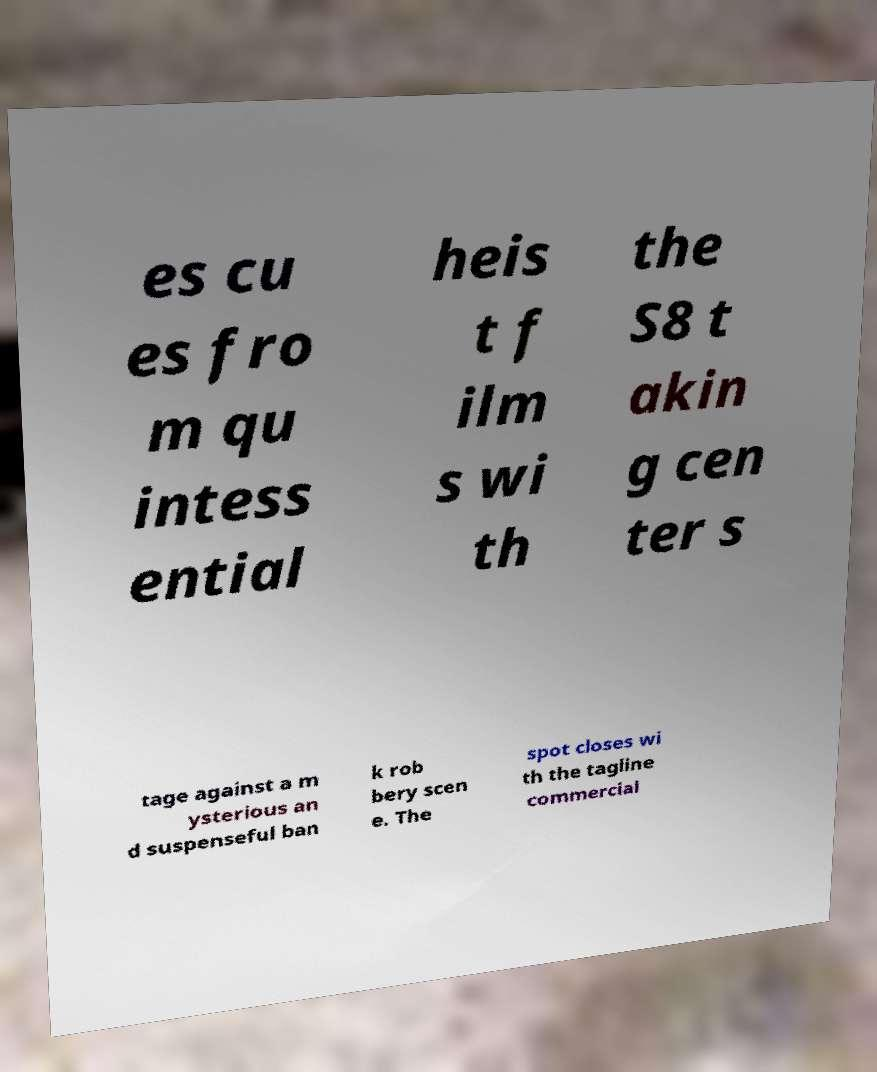Could you extract and type out the text from this image? es cu es fro m qu intess ential heis t f ilm s wi th the S8 t akin g cen ter s tage against a m ysterious an d suspenseful ban k rob bery scen e. The spot closes wi th the tagline commercial 